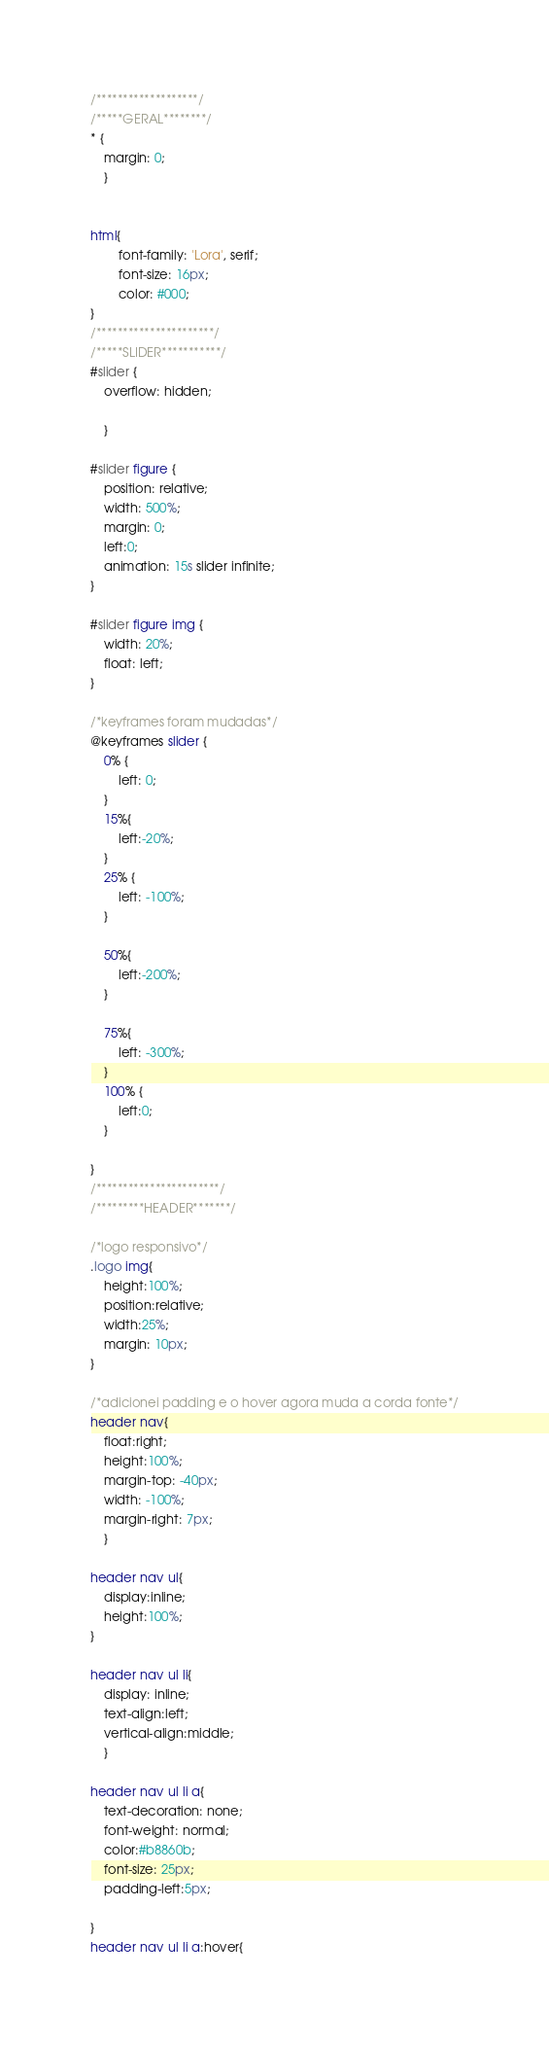Convert code to text. <code><loc_0><loc_0><loc_500><loc_500><_CSS_>/*******************/
/*****GERAL********/
* {
    margin: 0;
    }
    
    
html{
        font-family: 'Lora', serif;
        font-size: 16px;
        color: #000;
}
/**********************/
/*****SLIDER***********/
#slider {
    overflow: hidden;
    
    }

#slider figure {
    position: relative;
    width: 500%;
    margin: 0;
    left:0;
    animation: 15s slider infinite;
}

#slider figure img {
    width: 20%;    
    float: left;
}

/*keyframes foram mudadas*/
@keyframes slider {
    0% {
        left: 0;
    }
    15%{
        left:-20%;
    }
    25% {
        left: -100%;
    }

    50%{
        left:-200%;
    }

    75%{
        left: -300%;
    }
    100% {
        left:0;
    }

}
/***********************/
/*********HEADER*******/

/*logo responsivo*/
.logo img{
    height:100%;
    position:relative;
    width:25%;
    margin: 10px;
}

/*adicionei padding e o hover agora muda a corda fonte*/
header nav{
    float:right;
    height:100%;
    margin-top: -40px;   
    width: -100%;
    margin-right: 7px;
    }

header nav ul{
    display:inline;
    height:100%;
}

header nav ul li{
    display: inline;
    text-align:left;
    vertical-align:middle;
    }

header nav ul li a{
    text-decoration: none;    
    font-weight: normal;
    color:#b8860b;
    font-size: 25px;
    padding-left:5px;

}
header nav ul li a:hover{</code> 